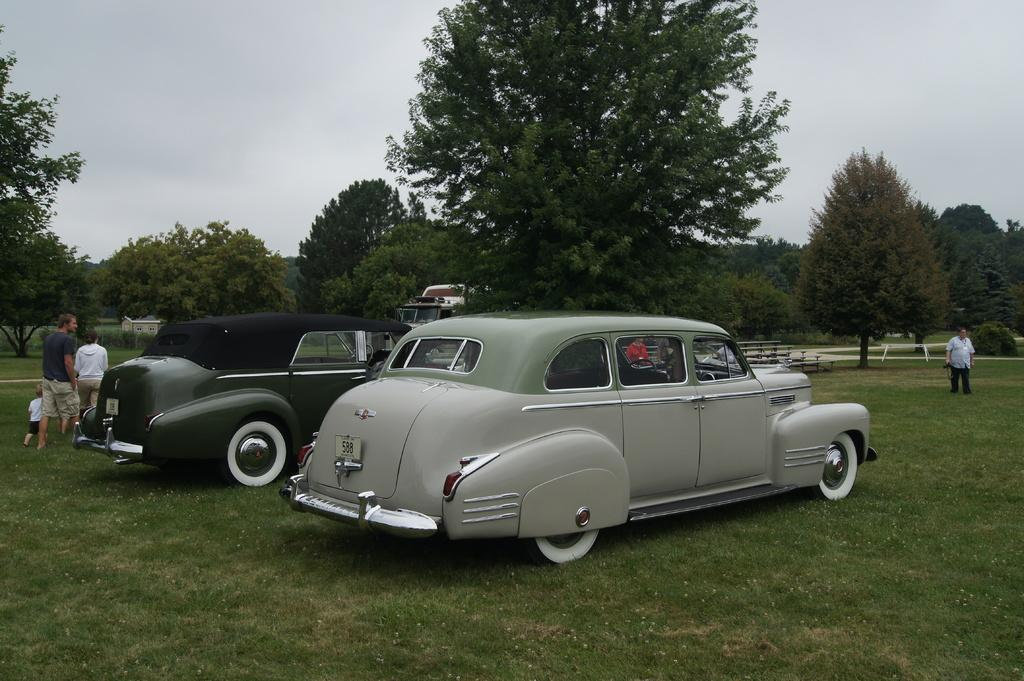What is located in the center of the image? There are vehicles in the center of the image. What can be seen in the background of the image? Sky, trees, plants, grass, and people are visible in the background of the image. Can you describe the natural elements present in the background? There are trees, plants, and grass in the background of the image. Are there any people present in the image? Yes, there are people standing in the background of the image. What type of feather can be seen falling from the sky in the image? There is no feather falling from the sky in the image; only vehicles, sky, trees, plants, grass, and people are present. 